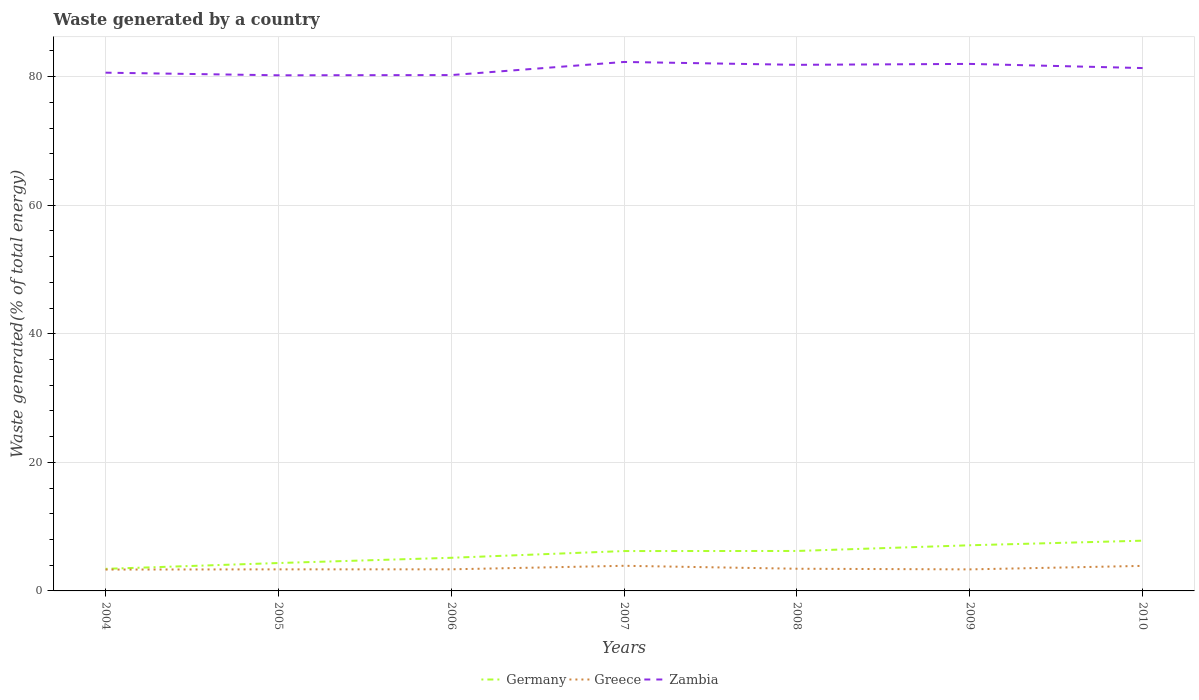Does the line corresponding to Germany intersect with the line corresponding to Zambia?
Your answer should be compact. No. Is the number of lines equal to the number of legend labels?
Provide a succinct answer. Yes. Across all years, what is the maximum total waste generated in Greece?
Your answer should be compact. 3.32. What is the total total waste generated in Germany in the graph?
Keep it short and to the point. -1.86. What is the difference between the highest and the second highest total waste generated in Zambia?
Provide a short and direct response. 2.08. What is the difference between the highest and the lowest total waste generated in Zambia?
Offer a very short reply. 4. How many lines are there?
Your answer should be compact. 3. Where does the legend appear in the graph?
Make the answer very short. Bottom center. How are the legend labels stacked?
Keep it short and to the point. Horizontal. What is the title of the graph?
Give a very brief answer. Waste generated by a country. Does "Fiji" appear as one of the legend labels in the graph?
Your response must be concise. No. What is the label or title of the X-axis?
Offer a terse response. Years. What is the label or title of the Y-axis?
Provide a succinct answer. Waste generated(% of total energy). What is the Waste generated(% of total energy) of Germany in 2004?
Your response must be concise. 3.43. What is the Waste generated(% of total energy) of Greece in 2004?
Give a very brief answer. 3.32. What is the Waste generated(% of total energy) in Zambia in 2004?
Your answer should be very brief. 80.61. What is the Waste generated(% of total energy) in Germany in 2005?
Ensure brevity in your answer.  4.34. What is the Waste generated(% of total energy) in Greece in 2005?
Provide a short and direct response. 3.35. What is the Waste generated(% of total energy) of Zambia in 2005?
Make the answer very short. 80.2. What is the Waste generated(% of total energy) in Germany in 2006?
Offer a very short reply. 5.15. What is the Waste generated(% of total energy) of Greece in 2006?
Your response must be concise. 3.36. What is the Waste generated(% of total energy) in Zambia in 2006?
Your response must be concise. 80.24. What is the Waste generated(% of total energy) of Germany in 2007?
Ensure brevity in your answer.  6.2. What is the Waste generated(% of total energy) of Greece in 2007?
Ensure brevity in your answer.  3.91. What is the Waste generated(% of total energy) in Zambia in 2007?
Your answer should be compact. 82.28. What is the Waste generated(% of total energy) in Germany in 2008?
Provide a succinct answer. 6.21. What is the Waste generated(% of total energy) in Greece in 2008?
Ensure brevity in your answer.  3.45. What is the Waste generated(% of total energy) in Zambia in 2008?
Provide a succinct answer. 81.83. What is the Waste generated(% of total energy) in Germany in 2009?
Ensure brevity in your answer.  7.1. What is the Waste generated(% of total energy) of Greece in 2009?
Your answer should be very brief. 3.35. What is the Waste generated(% of total energy) in Zambia in 2009?
Make the answer very short. 81.98. What is the Waste generated(% of total energy) in Germany in 2010?
Your response must be concise. 7.82. What is the Waste generated(% of total energy) in Greece in 2010?
Your answer should be very brief. 3.9. What is the Waste generated(% of total energy) in Zambia in 2010?
Your answer should be compact. 81.33. Across all years, what is the maximum Waste generated(% of total energy) of Germany?
Give a very brief answer. 7.82. Across all years, what is the maximum Waste generated(% of total energy) of Greece?
Provide a succinct answer. 3.91. Across all years, what is the maximum Waste generated(% of total energy) in Zambia?
Ensure brevity in your answer.  82.28. Across all years, what is the minimum Waste generated(% of total energy) in Germany?
Provide a succinct answer. 3.43. Across all years, what is the minimum Waste generated(% of total energy) of Greece?
Keep it short and to the point. 3.32. Across all years, what is the minimum Waste generated(% of total energy) in Zambia?
Provide a short and direct response. 80.2. What is the total Waste generated(% of total energy) of Germany in the graph?
Make the answer very short. 40.26. What is the total Waste generated(% of total energy) of Greece in the graph?
Offer a very short reply. 24.64. What is the total Waste generated(% of total energy) in Zambia in the graph?
Your response must be concise. 568.48. What is the difference between the Waste generated(% of total energy) of Germany in 2004 and that in 2005?
Make the answer very short. -0.91. What is the difference between the Waste generated(% of total energy) of Greece in 2004 and that in 2005?
Your answer should be very brief. -0.03. What is the difference between the Waste generated(% of total energy) in Zambia in 2004 and that in 2005?
Keep it short and to the point. 0.41. What is the difference between the Waste generated(% of total energy) of Germany in 2004 and that in 2006?
Your answer should be very brief. -1.72. What is the difference between the Waste generated(% of total energy) of Greece in 2004 and that in 2006?
Give a very brief answer. -0.04. What is the difference between the Waste generated(% of total energy) in Zambia in 2004 and that in 2006?
Your answer should be very brief. 0.37. What is the difference between the Waste generated(% of total energy) in Germany in 2004 and that in 2007?
Offer a very short reply. -2.77. What is the difference between the Waste generated(% of total energy) in Greece in 2004 and that in 2007?
Give a very brief answer. -0.59. What is the difference between the Waste generated(% of total energy) of Zambia in 2004 and that in 2007?
Keep it short and to the point. -1.67. What is the difference between the Waste generated(% of total energy) of Germany in 2004 and that in 2008?
Give a very brief answer. -2.78. What is the difference between the Waste generated(% of total energy) in Greece in 2004 and that in 2008?
Provide a short and direct response. -0.13. What is the difference between the Waste generated(% of total energy) of Zambia in 2004 and that in 2008?
Your answer should be very brief. -1.22. What is the difference between the Waste generated(% of total energy) in Germany in 2004 and that in 2009?
Give a very brief answer. -3.67. What is the difference between the Waste generated(% of total energy) in Greece in 2004 and that in 2009?
Ensure brevity in your answer.  -0.03. What is the difference between the Waste generated(% of total energy) of Zambia in 2004 and that in 2009?
Keep it short and to the point. -1.36. What is the difference between the Waste generated(% of total energy) in Germany in 2004 and that in 2010?
Your answer should be compact. -4.38. What is the difference between the Waste generated(% of total energy) in Greece in 2004 and that in 2010?
Give a very brief answer. -0.57. What is the difference between the Waste generated(% of total energy) in Zambia in 2004 and that in 2010?
Your response must be concise. -0.72. What is the difference between the Waste generated(% of total energy) in Germany in 2005 and that in 2006?
Your response must be concise. -0.82. What is the difference between the Waste generated(% of total energy) in Greece in 2005 and that in 2006?
Your response must be concise. -0.01. What is the difference between the Waste generated(% of total energy) of Zambia in 2005 and that in 2006?
Give a very brief answer. -0.04. What is the difference between the Waste generated(% of total energy) of Germany in 2005 and that in 2007?
Keep it short and to the point. -1.86. What is the difference between the Waste generated(% of total energy) of Greece in 2005 and that in 2007?
Provide a short and direct response. -0.55. What is the difference between the Waste generated(% of total energy) in Zambia in 2005 and that in 2007?
Your response must be concise. -2.08. What is the difference between the Waste generated(% of total energy) of Germany in 2005 and that in 2008?
Offer a terse response. -1.88. What is the difference between the Waste generated(% of total energy) of Greece in 2005 and that in 2008?
Offer a terse response. -0.1. What is the difference between the Waste generated(% of total energy) of Zambia in 2005 and that in 2008?
Keep it short and to the point. -1.63. What is the difference between the Waste generated(% of total energy) of Germany in 2005 and that in 2009?
Offer a terse response. -2.76. What is the difference between the Waste generated(% of total energy) in Greece in 2005 and that in 2009?
Your answer should be compact. 0. What is the difference between the Waste generated(% of total energy) of Zambia in 2005 and that in 2009?
Your response must be concise. -1.77. What is the difference between the Waste generated(% of total energy) in Germany in 2005 and that in 2010?
Ensure brevity in your answer.  -3.48. What is the difference between the Waste generated(% of total energy) in Greece in 2005 and that in 2010?
Offer a very short reply. -0.54. What is the difference between the Waste generated(% of total energy) of Zambia in 2005 and that in 2010?
Offer a terse response. -1.13. What is the difference between the Waste generated(% of total energy) of Germany in 2006 and that in 2007?
Offer a terse response. -1.05. What is the difference between the Waste generated(% of total energy) of Greece in 2006 and that in 2007?
Offer a very short reply. -0.55. What is the difference between the Waste generated(% of total energy) in Zambia in 2006 and that in 2007?
Ensure brevity in your answer.  -2.04. What is the difference between the Waste generated(% of total energy) of Germany in 2006 and that in 2008?
Your response must be concise. -1.06. What is the difference between the Waste generated(% of total energy) in Greece in 2006 and that in 2008?
Give a very brief answer. -0.09. What is the difference between the Waste generated(% of total energy) of Zambia in 2006 and that in 2008?
Your answer should be very brief. -1.59. What is the difference between the Waste generated(% of total energy) in Germany in 2006 and that in 2009?
Provide a succinct answer. -1.95. What is the difference between the Waste generated(% of total energy) of Greece in 2006 and that in 2009?
Offer a terse response. 0.01. What is the difference between the Waste generated(% of total energy) in Zambia in 2006 and that in 2009?
Provide a short and direct response. -1.74. What is the difference between the Waste generated(% of total energy) in Germany in 2006 and that in 2010?
Offer a terse response. -2.66. What is the difference between the Waste generated(% of total energy) of Greece in 2006 and that in 2010?
Provide a succinct answer. -0.53. What is the difference between the Waste generated(% of total energy) in Zambia in 2006 and that in 2010?
Offer a terse response. -1.09. What is the difference between the Waste generated(% of total energy) in Germany in 2007 and that in 2008?
Make the answer very short. -0.01. What is the difference between the Waste generated(% of total energy) in Greece in 2007 and that in 2008?
Your answer should be compact. 0.46. What is the difference between the Waste generated(% of total energy) in Zambia in 2007 and that in 2008?
Give a very brief answer. 0.45. What is the difference between the Waste generated(% of total energy) of Germany in 2007 and that in 2009?
Give a very brief answer. -0.9. What is the difference between the Waste generated(% of total energy) of Greece in 2007 and that in 2009?
Offer a terse response. 0.56. What is the difference between the Waste generated(% of total energy) in Zambia in 2007 and that in 2009?
Offer a very short reply. 0.3. What is the difference between the Waste generated(% of total energy) in Germany in 2007 and that in 2010?
Your answer should be very brief. -1.61. What is the difference between the Waste generated(% of total energy) in Greece in 2007 and that in 2010?
Your response must be concise. 0.01. What is the difference between the Waste generated(% of total energy) of Zambia in 2007 and that in 2010?
Give a very brief answer. 0.95. What is the difference between the Waste generated(% of total energy) of Germany in 2008 and that in 2009?
Ensure brevity in your answer.  -0.89. What is the difference between the Waste generated(% of total energy) of Greece in 2008 and that in 2009?
Your answer should be compact. 0.1. What is the difference between the Waste generated(% of total energy) in Zambia in 2008 and that in 2009?
Make the answer very short. -0.14. What is the difference between the Waste generated(% of total energy) of Germany in 2008 and that in 2010?
Your answer should be compact. -1.6. What is the difference between the Waste generated(% of total energy) in Greece in 2008 and that in 2010?
Make the answer very short. -0.45. What is the difference between the Waste generated(% of total energy) in Zambia in 2008 and that in 2010?
Your response must be concise. 0.5. What is the difference between the Waste generated(% of total energy) in Germany in 2009 and that in 2010?
Keep it short and to the point. -0.71. What is the difference between the Waste generated(% of total energy) in Greece in 2009 and that in 2010?
Provide a succinct answer. -0.54. What is the difference between the Waste generated(% of total energy) in Zambia in 2009 and that in 2010?
Give a very brief answer. 0.65. What is the difference between the Waste generated(% of total energy) of Germany in 2004 and the Waste generated(% of total energy) of Greece in 2005?
Your answer should be compact. 0.08. What is the difference between the Waste generated(% of total energy) in Germany in 2004 and the Waste generated(% of total energy) in Zambia in 2005?
Your response must be concise. -76.77. What is the difference between the Waste generated(% of total energy) in Greece in 2004 and the Waste generated(% of total energy) in Zambia in 2005?
Ensure brevity in your answer.  -76.88. What is the difference between the Waste generated(% of total energy) of Germany in 2004 and the Waste generated(% of total energy) of Greece in 2006?
Your answer should be compact. 0.07. What is the difference between the Waste generated(% of total energy) in Germany in 2004 and the Waste generated(% of total energy) in Zambia in 2006?
Ensure brevity in your answer.  -76.81. What is the difference between the Waste generated(% of total energy) in Greece in 2004 and the Waste generated(% of total energy) in Zambia in 2006?
Offer a very short reply. -76.92. What is the difference between the Waste generated(% of total energy) in Germany in 2004 and the Waste generated(% of total energy) in Greece in 2007?
Keep it short and to the point. -0.48. What is the difference between the Waste generated(% of total energy) in Germany in 2004 and the Waste generated(% of total energy) in Zambia in 2007?
Give a very brief answer. -78.85. What is the difference between the Waste generated(% of total energy) in Greece in 2004 and the Waste generated(% of total energy) in Zambia in 2007?
Provide a succinct answer. -78.96. What is the difference between the Waste generated(% of total energy) of Germany in 2004 and the Waste generated(% of total energy) of Greece in 2008?
Offer a terse response. -0.02. What is the difference between the Waste generated(% of total energy) in Germany in 2004 and the Waste generated(% of total energy) in Zambia in 2008?
Keep it short and to the point. -78.4. What is the difference between the Waste generated(% of total energy) of Greece in 2004 and the Waste generated(% of total energy) of Zambia in 2008?
Make the answer very short. -78.51. What is the difference between the Waste generated(% of total energy) of Germany in 2004 and the Waste generated(% of total energy) of Greece in 2009?
Your answer should be very brief. 0.08. What is the difference between the Waste generated(% of total energy) in Germany in 2004 and the Waste generated(% of total energy) in Zambia in 2009?
Keep it short and to the point. -78.54. What is the difference between the Waste generated(% of total energy) of Greece in 2004 and the Waste generated(% of total energy) of Zambia in 2009?
Your answer should be compact. -78.66. What is the difference between the Waste generated(% of total energy) in Germany in 2004 and the Waste generated(% of total energy) in Greece in 2010?
Keep it short and to the point. -0.46. What is the difference between the Waste generated(% of total energy) of Germany in 2004 and the Waste generated(% of total energy) of Zambia in 2010?
Provide a succinct answer. -77.9. What is the difference between the Waste generated(% of total energy) of Greece in 2004 and the Waste generated(% of total energy) of Zambia in 2010?
Give a very brief answer. -78.01. What is the difference between the Waste generated(% of total energy) of Germany in 2005 and the Waste generated(% of total energy) of Greece in 2006?
Offer a very short reply. 0.98. What is the difference between the Waste generated(% of total energy) of Germany in 2005 and the Waste generated(% of total energy) of Zambia in 2006?
Give a very brief answer. -75.9. What is the difference between the Waste generated(% of total energy) in Greece in 2005 and the Waste generated(% of total energy) in Zambia in 2006?
Make the answer very short. -76.89. What is the difference between the Waste generated(% of total energy) of Germany in 2005 and the Waste generated(% of total energy) of Greece in 2007?
Give a very brief answer. 0.43. What is the difference between the Waste generated(% of total energy) of Germany in 2005 and the Waste generated(% of total energy) of Zambia in 2007?
Give a very brief answer. -77.94. What is the difference between the Waste generated(% of total energy) in Greece in 2005 and the Waste generated(% of total energy) in Zambia in 2007?
Offer a terse response. -78.93. What is the difference between the Waste generated(% of total energy) of Germany in 2005 and the Waste generated(% of total energy) of Greece in 2008?
Make the answer very short. 0.89. What is the difference between the Waste generated(% of total energy) of Germany in 2005 and the Waste generated(% of total energy) of Zambia in 2008?
Provide a succinct answer. -77.5. What is the difference between the Waste generated(% of total energy) in Greece in 2005 and the Waste generated(% of total energy) in Zambia in 2008?
Provide a short and direct response. -78.48. What is the difference between the Waste generated(% of total energy) in Germany in 2005 and the Waste generated(% of total energy) in Greece in 2009?
Your answer should be very brief. 0.99. What is the difference between the Waste generated(% of total energy) of Germany in 2005 and the Waste generated(% of total energy) of Zambia in 2009?
Your response must be concise. -77.64. What is the difference between the Waste generated(% of total energy) of Greece in 2005 and the Waste generated(% of total energy) of Zambia in 2009?
Give a very brief answer. -78.62. What is the difference between the Waste generated(% of total energy) in Germany in 2005 and the Waste generated(% of total energy) in Greece in 2010?
Offer a very short reply. 0.44. What is the difference between the Waste generated(% of total energy) of Germany in 2005 and the Waste generated(% of total energy) of Zambia in 2010?
Keep it short and to the point. -76.99. What is the difference between the Waste generated(% of total energy) in Greece in 2005 and the Waste generated(% of total energy) in Zambia in 2010?
Offer a very short reply. -77.98. What is the difference between the Waste generated(% of total energy) of Germany in 2006 and the Waste generated(% of total energy) of Greece in 2007?
Give a very brief answer. 1.25. What is the difference between the Waste generated(% of total energy) of Germany in 2006 and the Waste generated(% of total energy) of Zambia in 2007?
Provide a succinct answer. -77.13. What is the difference between the Waste generated(% of total energy) of Greece in 2006 and the Waste generated(% of total energy) of Zambia in 2007?
Provide a succinct answer. -78.92. What is the difference between the Waste generated(% of total energy) in Germany in 2006 and the Waste generated(% of total energy) in Greece in 2008?
Ensure brevity in your answer.  1.7. What is the difference between the Waste generated(% of total energy) in Germany in 2006 and the Waste generated(% of total energy) in Zambia in 2008?
Your answer should be very brief. -76.68. What is the difference between the Waste generated(% of total energy) in Greece in 2006 and the Waste generated(% of total energy) in Zambia in 2008?
Your answer should be compact. -78.47. What is the difference between the Waste generated(% of total energy) in Germany in 2006 and the Waste generated(% of total energy) in Greece in 2009?
Provide a succinct answer. 1.8. What is the difference between the Waste generated(% of total energy) of Germany in 2006 and the Waste generated(% of total energy) of Zambia in 2009?
Offer a terse response. -76.82. What is the difference between the Waste generated(% of total energy) of Greece in 2006 and the Waste generated(% of total energy) of Zambia in 2009?
Provide a succinct answer. -78.62. What is the difference between the Waste generated(% of total energy) of Germany in 2006 and the Waste generated(% of total energy) of Greece in 2010?
Make the answer very short. 1.26. What is the difference between the Waste generated(% of total energy) of Germany in 2006 and the Waste generated(% of total energy) of Zambia in 2010?
Keep it short and to the point. -76.18. What is the difference between the Waste generated(% of total energy) in Greece in 2006 and the Waste generated(% of total energy) in Zambia in 2010?
Your response must be concise. -77.97. What is the difference between the Waste generated(% of total energy) in Germany in 2007 and the Waste generated(% of total energy) in Greece in 2008?
Your response must be concise. 2.75. What is the difference between the Waste generated(% of total energy) of Germany in 2007 and the Waste generated(% of total energy) of Zambia in 2008?
Provide a short and direct response. -75.63. What is the difference between the Waste generated(% of total energy) in Greece in 2007 and the Waste generated(% of total energy) in Zambia in 2008?
Give a very brief answer. -77.93. What is the difference between the Waste generated(% of total energy) of Germany in 2007 and the Waste generated(% of total energy) of Greece in 2009?
Offer a terse response. 2.85. What is the difference between the Waste generated(% of total energy) of Germany in 2007 and the Waste generated(% of total energy) of Zambia in 2009?
Keep it short and to the point. -75.78. What is the difference between the Waste generated(% of total energy) of Greece in 2007 and the Waste generated(% of total energy) of Zambia in 2009?
Keep it short and to the point. -78.07. What is the difference between the Waste generated(% of total energy) in Germany in 2007 and the Waste generated(% of total energy) in Greece in 2010?
Ensure brevity in your answer.  2.31. What is the difference between the Waste generated(% of total energy) of Germany in 2007 and the Waste generated(% of total energy) of Zambia in 2010?
Your answer should be very brief. -75.13. What is the difference between the Waste generated(% of total energy) in Greece in 2007 and the Waste generated(% of total energy) in Zambia in 2010?
Your answer should be very brief. -77.42. What is the difference between the Waste generated(% of total energy) in Germany in 2008 and the Waste generated(% of total energy) in Greece in 2009?
Give a very brief answer. 2.86. What is the difference between the Waste generated(% of total energy) in Germany in 2008 and the Waste generated(% of total energy) in Zambia in 2009?
Your response must be concise. -75.76. What is the difference between the Waste generated(% of total energy) in Greece in 2008 and the Waste generated(% of total energy) in Zambia in 2009?
Give a very brief answer. -78.53. What is the difference between the Waste generated(% of total energy) of Germany in 2008 and the Waste generated(% of total energy) of Greece in 2010?
Your answer should be very brief. 2.32. What is the difference between the Waste generated(% of total energy) in Germany in 2008 and the Waste generated(% of total energy) in Zambia in 2010?
Ensure brevity in your answer.  -75.12. What is the difference between the Waste generated(% of total energy) of Greece in 2008 and the Waste generated(% of total energy) of Zambia in 2010?
Give a very brief answer. -77.88. What is the difference between the Waste generated(% of total energy) of Germany in 2009 and the Waste generated(% of total energy) of Greece in 2010?
Provide a succinct answer. 3.21. What is the difference between the Waste generated(% of total energy) in Germany in 2009 and the Waste generated(% of total energy) in Zambia in 2010?
Your response must be concise. -74.23. What is the difference between the Waste generated(% of total energy) of Greece in 2009 and the Waste generated(% of total energy) of Zambia in 2010?
Offer a very short reply. -77.98. What is the average Waste generated(% of total energy) of Germany per year?
Provide a short and direct response. 5.75. What is the average Waste generated(% of total energy) in Greece per year?
Offer a very short reply. 3.52. What is the average Waste generated(% of total energy) of Zambia per year?
Ensure brevity in your answer.  81.21. In the year 2004, what is the difference between the Waste generated(% of total energy) in Germany and Waste generated(% of total energy) in Greece?
Your answer should be very brief. 0.11. In the year 2004, what is the difference between the Waste generated(% of total energy) of Germany and Waste generated(% of total energy) of Zambia?
Offer a very short reply. -77.18. In the year 2004, what is the difference between the Waste generated(% of total energy) in Greece and Waste generated(% of total energy) in Zambia?
Give a very brief answer. -77.29. In the year 2005, what is the difference between the Waste generated(% of total energy) of Germany and Waste generated(% of total energy) of Greece?
Your answer should be very brief. 0.98. In the year 2005, what is the difference between the Waste generated(% of total energy) of Germany and Waste generated(% of total energy) of Zambia?
Your answer should be compact. -75.87. In the year 2005, what is the difference between the Waste generated(% of total energy) of Greece and Waste generated(% of total energy) of Zambia?
Provide a short and direct response. -76.85. In the year 2006, what is the difference between the Waste generated(% of total energy) of Germany and Waste generated(% of total energy) of Greece?
Your response must be concise. 1.79. In the year 2006, what is the difference between the Waste generated(% of total energy) of Germany and Waste generated(% of total energy) of Zambia?
Ensure brevity in your answer.  -75.09. In the year 2006, what is the difference between the Waste generated(% of total energy) in Greece and Waste generated(% of total energy) in Zambia?
Make the answer very short. -76.88. In the year 2007, what is the difference between the Waste generated(% of total energy) of Germany and Waste generated(% of total energy) of Greece?
Make the answer very short. 2.29. In the year 2007, what is the difference between the Waste generated(% of total energy) of Germany and Waste generated(% of total energy) of Zambia?
Offer a terse response. -76.08. In the year 2007, what is the difference between the Waste generated(% of total energy) of Greece and Waste generated(% of total energy) of Zambia?
Make the answer very short. -78.37. In the year 2008, what is the difference between the Waste generated(% of total energy) of Germany and Waste generated(% of total energy) of Greece?
Your response must be concise. 2.76. In the year 2008, what is the difference between the Waste generated(% of total energy) in Germany and Waste generated(% of total energy) in Zambia?
Ensure brevity in your answer.  -75.62. In the year 2008, what is the difference between the Waste generated(% of total energy) of Greece and Waste generated(% of total energy) of Zambia?
Keep it short and to the point. -78.38. In the year 2009, what is the difference between the Waste generated(% of total energy) in Germany and Waste generated(% of total energy) in Greece?
Your response must be concise. 3.75. In the year 2009, what is the difference between the Waste generated(% of total energy) in Germany and Waste generated(% of total energy) in Zambia?
Provide a short and direct response. -74.88. In the year 2009, what is the difference between the Waste generated(% of total energy) of Greece and Waste generated(% of total energy) of Zambia?
Give a very brief answer. -78.63. In the year 2010, what is the difference between the Waste generated(% of total energy) of Germany and Waste generated(% of total energy) of Greece?
Offer a terse response. 3.92. In the year 2010, what is the difference between the Waste generated(% of total energy) in Germany and Waste generated(% of total energy) in Zambia?
Your answer should be compact. -73.52. In the year 2010, what is the difference between the Waste generated(% of total energy) in Greece and Waste generated(% of total energy) in Zambia?
Offer a terse response. -77.44. What is the ratio of the Waste generated(% of total energy) in Germany in 2004 to that in 2005?
Offer a very short reply. 0.79. What is the ratio of the Waste generated(% of total energy) of Greece in 2004 to that in 2005?
Give a very brief answer. 0.99. What is the ratio of the Waste generated(% of total energy) of Germany in 2004 to that in 2006?
Provide a short and direct response. 0.67. What is the ratio of the Waste generated(% of total energy) of Zambia in 2004 to that in 2006?
Make the answer very short. 1. What is the ratio of the Waste generated(% of total energy) in Germany in 2004 to that in 2007?
Your answer should be very brief. 0.55. What is the ratio of the Waste generated(% of total energy) of Zambia in 2004 to that in 2007?
Your answer should be compact. 0.98. What is the ratio of the Waste generated(% of total energy) of Germany in 2004 to that in 2008?
Offer a very short reply. 0.55. What is the ratio of the Waste generated(% of total energy) in Greece in 2004 to that in 2008?
Keep it short and to the point. 0.96. What is the ratio of the Waste generated(% of total energy) in Zambia in 2004 to that in 2008?
Ensure brevity in your answer.  0.99. What is the ratio of the Waste generated(% of total energy) in Germany in 2004 to that in 2009?
Provide a short and direct response. 0.48. What is the ratio of the Waste generated(% of total energy) of Greece in 2004 to that in 2009?
Your answer should be very brief. 0.99. What is the ratio of the Waste generated(% of total energy) in Zambia in 2004 to that in 2009?
Your answer should be very brief. 0.98. What is the ratio of the Waste generated(% of total energy) in Germany in 2004 to that in 2010?
Make the answer very short. 0.44. What is the ratio of the Waste generated(% of total energy) of Greece in 2004 to that in 2010?
Give a very brief answer. 0.85. What is the ratio of the Waste generated(% of total energy) in Germany in 2005 to that in 2006?
Offer a terse response. 0.84. What is the ratio of the Waste generated(% of total energy) in Greece in 2005 to that in 2006?
Offer a very short reply. 1. What is the ratio of the Waste generated(% of total energy) of Germany in 2005 to that in 2007?
Offer a terse response. 0.7. What is the ratio of the Waste generated(% of total energy) of Greece in 2005 to that in 2007?
Provide a short and direct response. 0.86. What is the ratio of the Waste generated(% of total energy) of Zambia in 2005 to that in 2007?
Offer a very short reply. 0.97. What is the ratio of the Waste generated(% of total energy) of Germany in 2005 to that in 2008?
Offer a very short reply. 0.7. What is the ratio of the Waste generated(% of total energy) in Greece in 2005 to that in 2008?
Your response must be concise. 0.97. What is the ratio of the Waste generated(% of total energy) in Zambia in 2005 to that in 2008?
Your answer should be very brief. 0.98. What is the ratio of the Waste generated(% of total energy) of Germany in 2005 to that in 2009?
Keep it short and to the point. 0.61. What is the ratio of the Waste generated(% of total energy) of Greece in 2005 to that in 2009?
Offer a terse response. 1. What is the ratio of the Waste generated(% of total energy) of Zambia in 2005 to that in 2009?
Make the answer very short. 0.98. What is the ratio of the Waste generated(% of total energy) in Germany in 2005 to that in 2010?
Your answer should be compact. 0.56. What is the ratio of the Waste generated(% of total energy) in Greece in 2005 to that in 2010?
Provide a succinct answer. 0.86. What is the ratio of the Waste generated(% of total energy) in Zambia in 2005 to that in 2010?
Your response must be concise. 0.99. What is the ratio of the Waste generated(% of total energy) of Germany in 2006 to that in 2007?
Your response must be concise. 0.83. What is the ratio of the Waste generated(% of total energy) of Greece in 2006 to that in 2007?
Your response must be concise. 0.86. What is the ratio of the Waste generated(% of total energy) of Zambia in 2006 to that in 2007?
Your answer should be compact. 0.98. What is the ratio of the Waste generated(% of total energy) of Germany in 2006 to that in 2008?
Give a very brief answer. 0.83. What is the ratio of the Waste generated(% of total energy) in Greece in 2006 to that in 2008?
Your answer should be compact. 0.97. What is the ratio of the Waste generated(% of total energy) in Zambia in 2006 to that in 2008?
Your answer should be compact. 0.98. What is the ratio of the Waste generated(% of total energy) of Germany in 2006 to that in 2009?
Your answer should be very brief. 0.73. What is the ratio of the Waste generated(% of total energy) in Greece in 2006 to that in 2009?
Provide a succinct answer. 1. What is the ratio of the Waste generated(% of total energy) in Zambia in 2006 to that in 2009?
Keep it short and to the point. 0.98. What is the ratio of the Waste generated(% of total energy) of Germany in 2006 to that in 2010?
Your answer should be compact. 0.66. What is the ratio of the Waste generated(% of total energy) in Greece in 2006 to that in 2010?
Provide a succinct answer. 0.86. What is the ratio of the Waste generated(% of total energy) in Zambia in 2006 to that in 2010?
Your response must be concise. 0.99. What is the ratio of the Waste generated(% of total energy) of Greece in 2007 to that in 2008?
Your answer should be very brief. 1.13. What is the ratio of the Waste generated(% of total energy) of Zambia in 2007 to that in 2008?
Offer a very short reply. 1.01. What is the ratio of the Waste generated(% of total energy) in Germany in 2007 to that in 2009?
Keep it short and to the point. 0.87. What is the ratio of the Waste generated(% of total energy) of Greece in 2007 to that in 2009?
Offer a terse response. 1.17. What is the ratio of the Waste generated(% of total energy) of Germany in 2007 to that in 2010?
Keep it short and to the point. 0.79. What is the ratio of the Waste generated(% of total energy) of Greece in 2007 to that in 2010?
Your answer should be very brief. 1. What is the ratio of the Waste generated(% of total energy) in Zambia in 2007 to that in 2010?
Ensure brevity in your answer.  1.01. What is the ratio of the Waste generated(% of total energy) in Germany in 2008 to that in 2009?
Make the answer very short. 0.88. What is the ratio of the Waste generated(% of total energy) in Greece in 2008 to that in 2009?
Give a very brief answer. 1.03. What is the ratio of the Waste generated(% of total energy) of Zambia in 2008 to that in 2009?
Your response must be concise. 1. What is the ratio of the Waste generated(% of total energy) in Germany in 2008 to that in 2010?
Your response must be concise. 0.8. What is the ratio of the Waste generated(% of total energy) in Greece in 2008 to that in 2010?
Keep it short and to the point. 0.89. What is the ratio of the Waste generated(% of total energy) in Zambia in 2008 to that in 2010?
Your response must be concise. 1.01. What is the ratio of the Waste generated(% of total energy) in Germany in 2009 to that in 2010?
Your response must be concise. 0.91. What is the ratio of the Waste generated(% of total energy) in Greece in 2009 to that in 2010?
Give a very brief answer. 0.86. What is the ratio of the Waste generated(% of total energy) in Zambia in 2009 to that in 2010?
Provide a short and direct response. 1.01. What is the difference between the highest and the second highest Waste generated(% of total energy) of Germany?
Make the answer very short. 0.71. What is the difference between the highest and the second highest Waste generated(% of total energy) of Greece?
Provide a succinct answer. 0.01. What is the difference between the highest and the second highest Waste generated(% of total energy) in Zambia?
Offer a very short reply. 0.3. What is the difference between the highest and the lowest Waste generated(% of total energy) of Germany?
Your answer should be compact. 4.38. What is the difference between the highest and the lowest Waste generated(% of total energy) in Greece?
Keep it short and to the point. 0.59. What is the difference between the highest and the lowest Waste generated(% of total energy) of Zambia?
Keep it short and to the point. 2.08. 